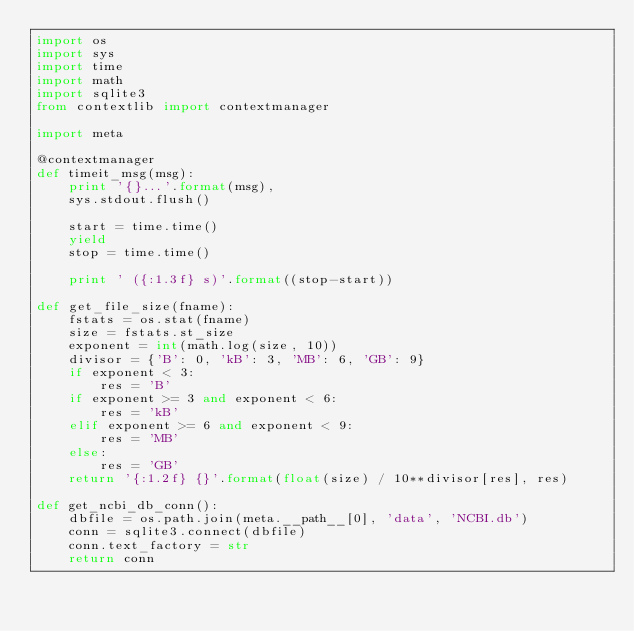<code> <loc_0><loc_0><loc_500><loc_500><_Python_>import os
import sys
import time
import math
import sqlite3
from contextlib import contextmanager

import meta

@contextmanager
def timeit_msg(msg):
	print '{}...'.format(msg),
	sys.stdout.flush()

	start = time.time()
	yield
	stop = time.time()

	print ' ({:1.3f} s)'.format((stop-start))

def get_file_size(fname):
	fstats = os.stat(fname)
	size = fstats.st_size
	exponent = int(math.log(size, 10))
	divisor = {'B': 0, 'kB': 3, 'MB': 6, 'GB': 9}
	if exponent < 3:
		res = 'B'
	if exponent >= 3 and exponent < 6:
		res = 'kB'
	elif exponent >= 6 and exponent < 9:
		res = 'MB'
	else:
		res = 'GB'
	return '{:1.2f} {}'.format(float(size) / 10**divisor[res], res)

def get_ncbi_db_conn():
	dbfile = os.path.join(meta.__path__[0], 'data', 'NCBI.db')
	conn = sqlite3.connect(dbfile)
	conn.text_factory = str
	return conn


</code> 